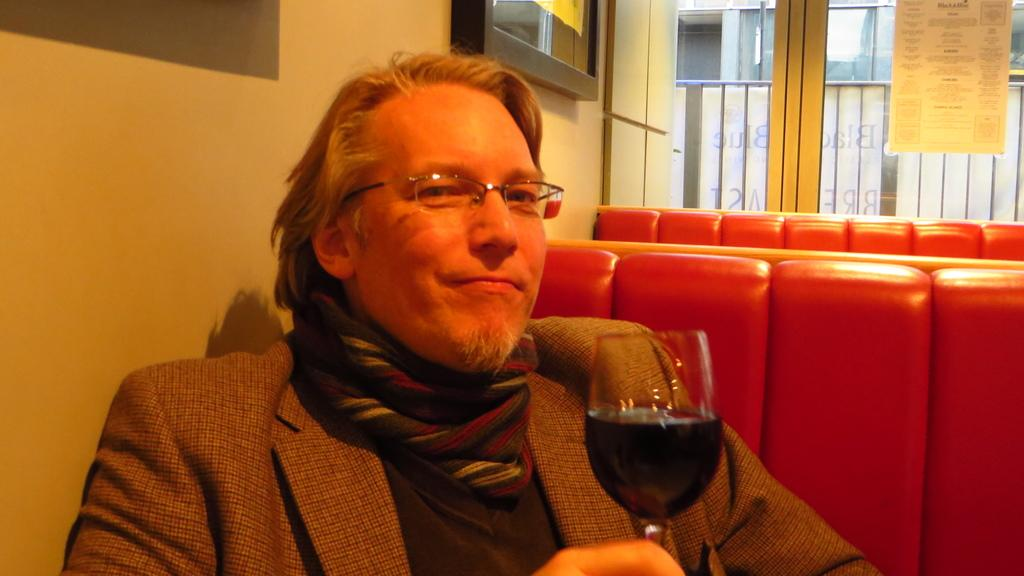What is the person in the image doing? The person is sitting on a chair in the image. What is the person wearing? The person is wearing a suit in the image. What is the person holding in his hand? The person is holding a glass of wine in his right hand in the image. What type of coal can be seen in the person's pocket in the image? There is no coal present in the image; the person is holding a glass of wine in his right hand. What color is the train in the background of the image? There is no train present in the image; it only features a person sitting on a chair. 